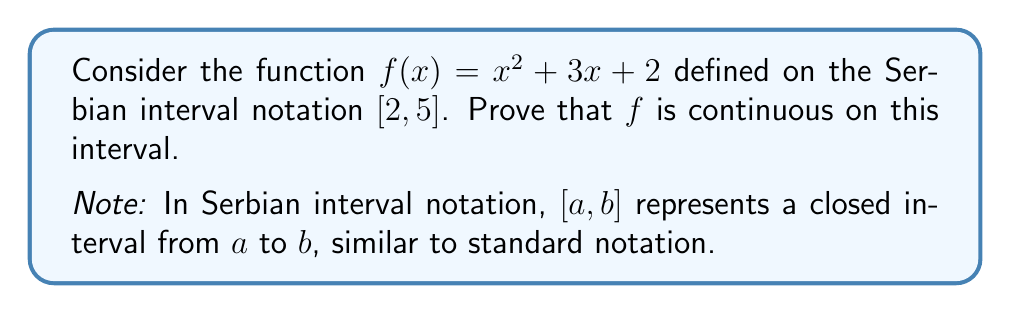Could you help me with this problem? To prove that $f(x) = x^2 + 3x + 2$ is continuous on the Serbian interval $[2, 5]$, we need to show that it is continuous at every point in this interval. We can do this by demonstrating that the function satisfies the definition of continuity for all $x_0 \in [2, 5]$.

Step 1: Recall the definition of continuity.
A function $f$ is continuous at a point $x_0$ if:
$$\lim_{x \to x_0} f(x) = f(x_0)$$

Step 2: Choose an arbitrary point $x_0 \in [2, 5]$.

Step 3: Calculate the limit of $f(x)$ as $x$ approaches $x_0$:
$$\lim_{x \to x_0} f(x) = \lim_{x \to x_0} (x^2 + 3x + 2)$$
$$= \lim_{x \to x_0} x^2 + \lim_{x \to x_0} 3x + \lim_{x \to x_0} 2$$
$$= x_0^2 + 3x_0 + 2$$
$$= f(x_0)$$

Step 4: Verify that this limit equals $f(x_0)$:
$f(x_0) = x_0^2 + 3x_0 + 2$, which is exactly what we found in Step 3.

Step 5: Conclude that since $\lim_{x \to x_0} f(x) = f(x_0)$ for any $x_0 \in [2, 5]$, $f(x)$ is continuous at every point in the interval.

Step 6: Note that the endpoints of the interval are included because $[2, 5]$ is a closed interval in Serbian notation, just as in standard notation.

Therefore, $f(x) = x^2 + 3x + 2$ is continuous on the entire Serbian interval $[2, 5]$.
Answer: The function $f(x) = x^2 + 3x + 2$ is continuous on the Serbian interval $[2, 5]$ because $\lim_{x \to x_0} f(x) = f(x_0)$ for all $x_0 \in [2, 5]$. 